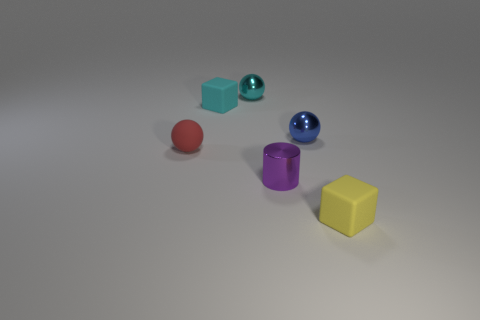Subtract all small cyan spheres. How many spheres are left? 2 Subtract all yellow blocks. How many blocks are left? 1 Add 2 big cylinders. How many objects exist? 8 Subtract all blocks. How many objects are left? 4 Subtract all cyan blocks. How many cyan spheres are left? 1 Add 3 rubber spheres. How many rubber spheres are left? 4 Add 5 yellow shiny cylinders. How many yellow shiny cylinders exist? 5 Subtract 1 blue spheres. How many objects are left? 5 Subtract 2 cubes. How many cubes are left? 0 Subtract all blue balls. Subtract all brown cubes. How many balls are left? 2 